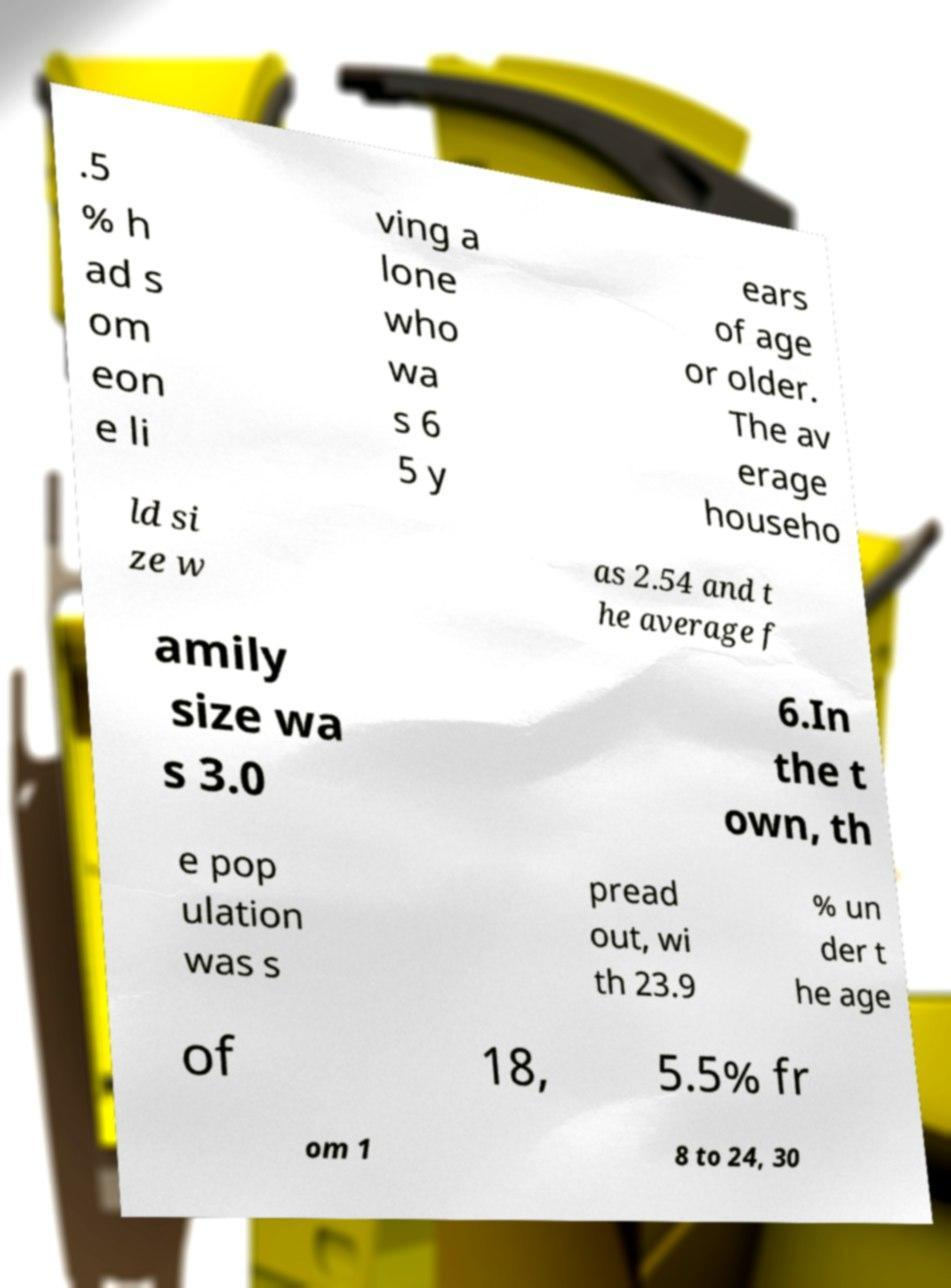Please identify and transcribe the text found in this image. .5 % h ad s om eon e li ving a lone who wa s 6 5 y ears of age or older. The av erage househo ld si ze w as 2.54 and t he average f amily size wa s 3.0 6.In the t own, th e pop ulation was s pread out, wi th 23.9 % un der t he age of 18, 5.5% fr om 1 8 to 24, 30 